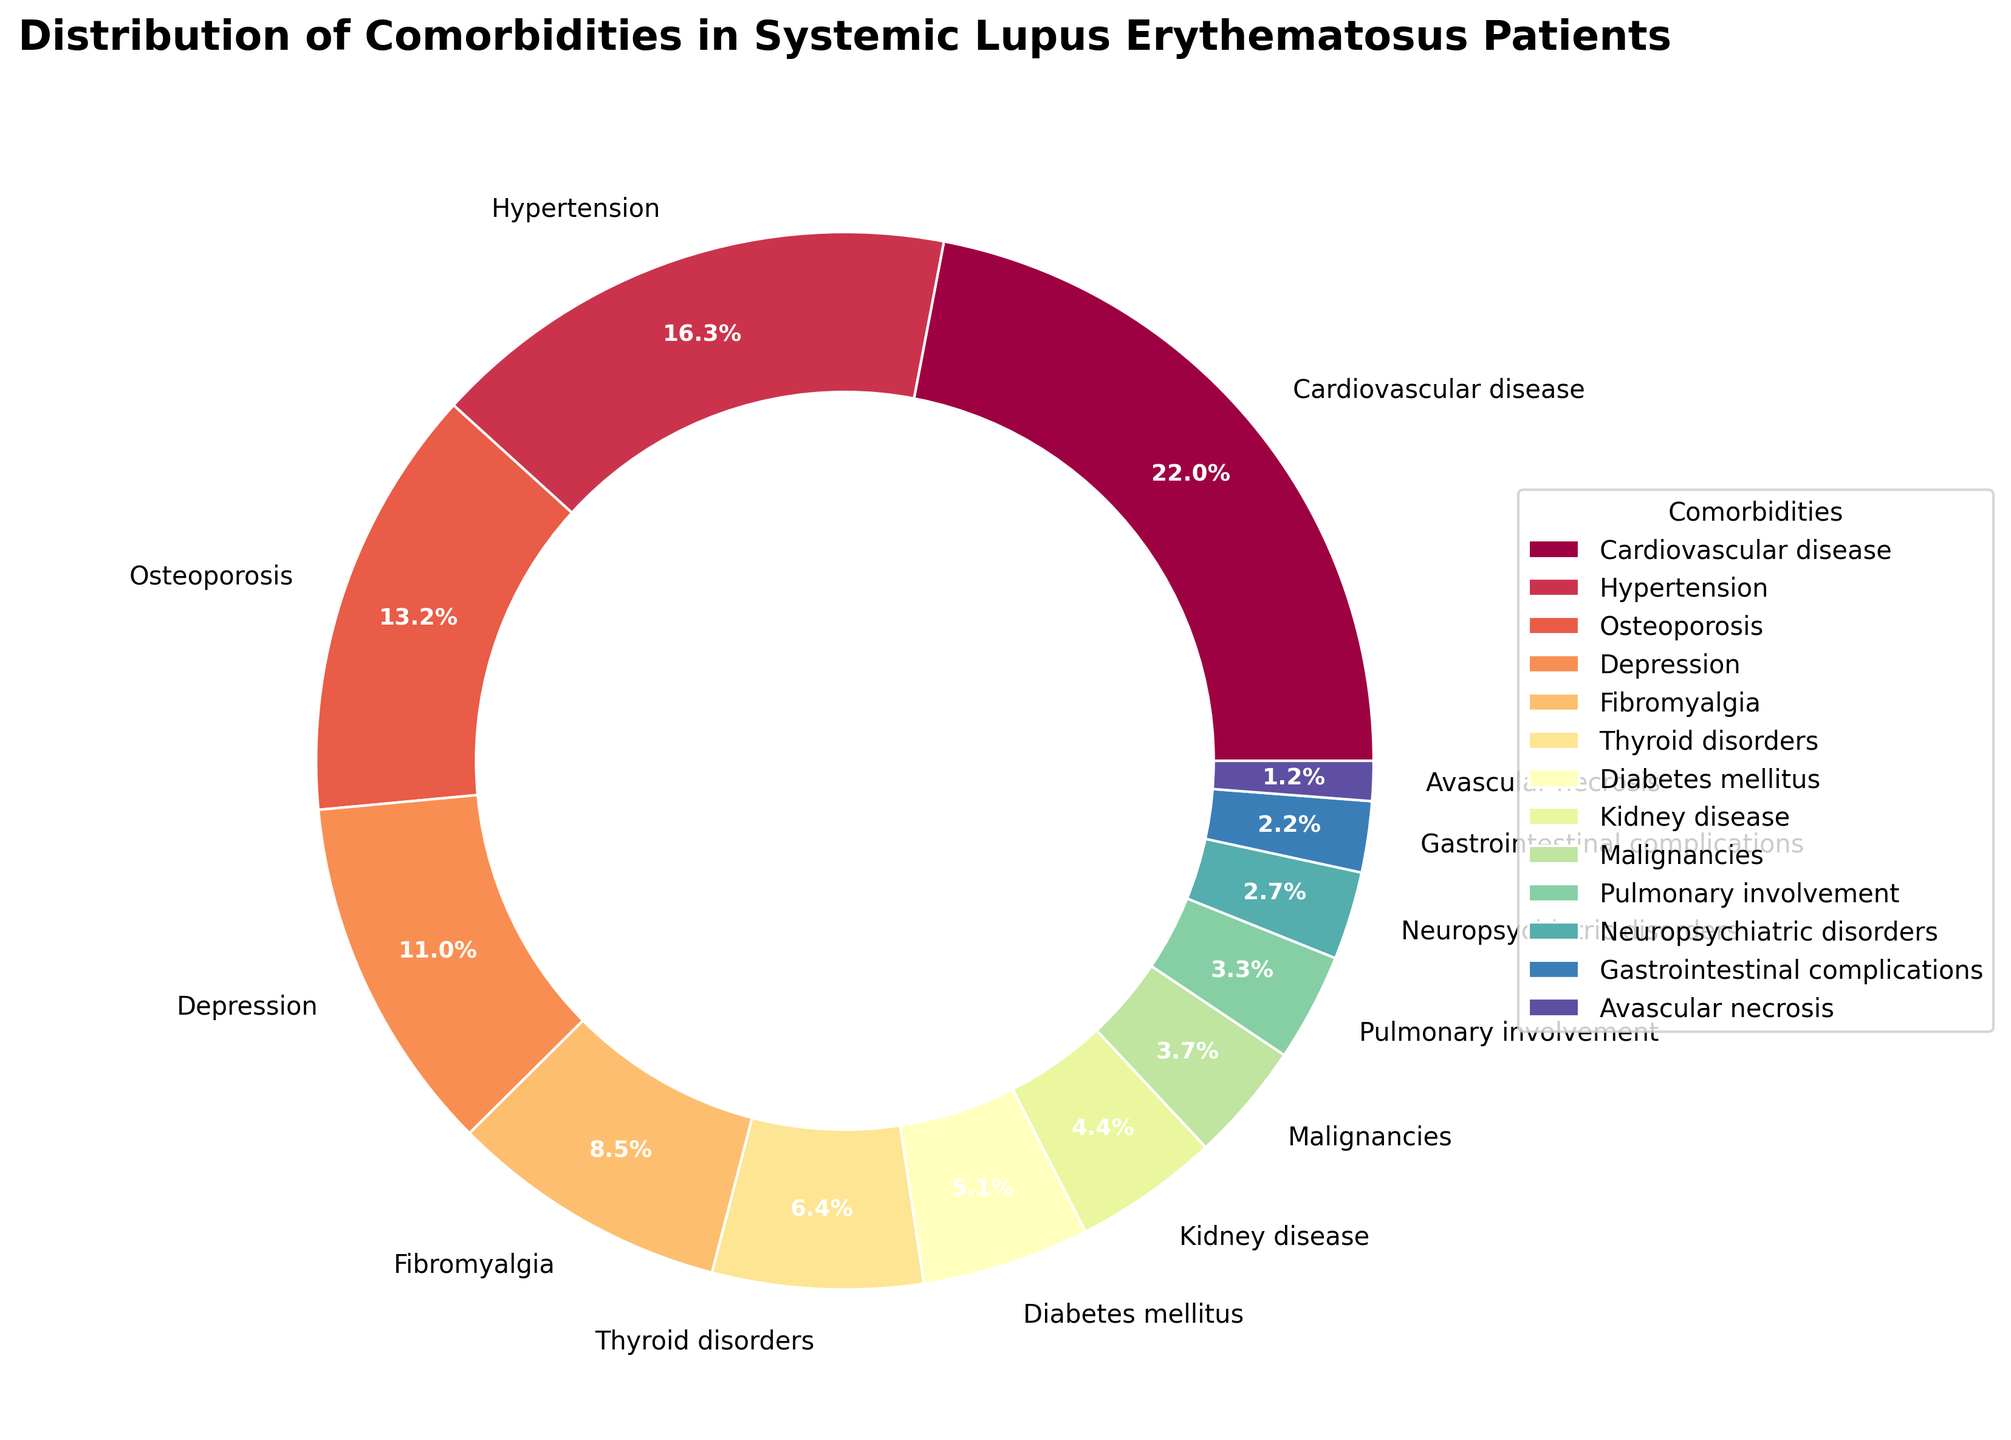What is the most common comorbidity among systemic lupus erythematosus patients? The most common comorbidity can be identified by looking at the slice with the largest percentage in the pie chart. Cardiovascular disease has the largest slice with 25.3%.
Answer: Cardiovascular disease What is the total percentage of patients with Hypertension and Diabetes mellitus? To find the total percentage, sum the percentages of Hypertension and Diabetes mellitus: 18.7% + 5.9%.
Answer: 24.6% Which comorbidity is less prevalent: Pulmonary involvement or Avascular necrosis? Compare the sizes of the slices for Pulmonary involvement (3.8%) and Avascular necrosis (1.4%). Avascular necrosis has a smaller percentage.
Answer: Avascular necrosis How much more common is Depression compared to Neuropsychiatric disorders? Subtract the percentage of Neuropsychiatric disorders (3.1%) from Depression (12.6%). 12.6% - 3.1% = 9.5%.
Answer: 9.5% What is the combined percentage of patients with Osteoporosis, Thyroid disorders, and Malignancies? Add the percentages for Osteoporosis (15.2%), Thyroid disorders (7.4%), and Malignancies (4.2%). 15.2% + 7.4% + 4.2% = 26.8%.
Answer: 26.8% Which comorbidity has a larger percentage, Kidney disease or Gastrointestinal complications? Compare the percentages of Kidney disease (5.1%) and Gastrointestinal complications (2.5%). Kidney disease has a larger percentage.
Answer: Kidney disease What percentage of comorbidities have a proportion less than 10% each? Identify comorbidities with slices less than 10%: Thyroid disorders (7.4%), Diabetes mellitus (5.9%), Kidney disease (5.1%), Malignancies (4.2%), Pulmonary involvement (3.8%), Neuropsychiatric disorders (3.1%), Gastrointestinal complications (2.5%), Avascular necrosis (1.4%). Count these slices: 8 out of 13. Calculate the percentage: (8/13)*100 ≈ 61.5%.
Answer: 61.5% Compare the percentage of patients with Fibromyalgia to the percentage of patients with Thyroid disorders and determine the difference. Subtract the percentage of Thyroid disorders (7.4%) from Fibromyalgia (9.8%). 9.8% - 7.4% = 2.4%.
Answer: 2.4% Arrange the top three most common comorbidities in descending order. List the percentages of the top three comorbidities: Cardiovascular disease (25.3%), Hypertension (18.7%), Osteoporosis (15.2%) in descending order.
Answer: Cardiovascular disease, Hypertension, Osteoporosis What is the least common comorbidity among systemic lupus erythematosus patients? The least common comorbidity can be identified by looking at the smallest slice in the pie chart. Avascular necrosis has the smallest slice with 1.4%.
Answer: Avascular necrosis 